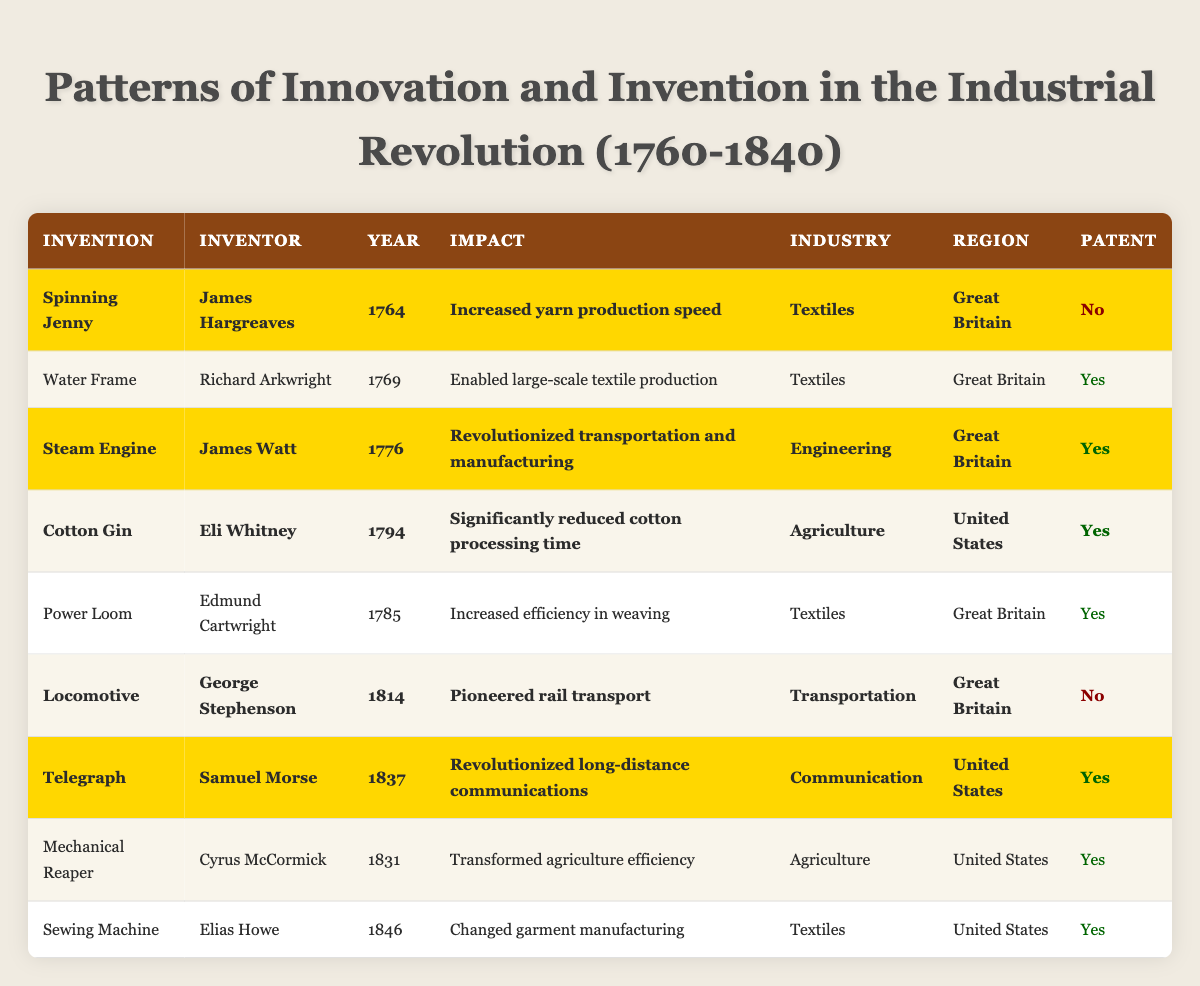What invention was created by James Hargreaves? The table lists James Hargreaves as the inventor of the Spinning Jenny.
Answer: Spinning Jenny Which invention significantly reduced cotton processing time? According to the table, the Cotton Gin, invented by Eli Whitney, is noted for significantly reducing cotton processing time.
Answer: Cotton Gin How many inventions highlighted in the table are from the United States? By counting the highlighted inventions from the United States, we identify three: Cotton Gin, Telegraph, and Locomotive.
Answer: 3 What year was the Steam Engine invented? The table indicates that the Steam Engine was invented in 1776.
Answer: 1776 Did Richard Arkwright patent the Water Frame? The table states that Richard Arkwright did patent the Water Frame, as indicated by "Yes" under the patent column for that invention.
Answer: Yes Which inventor is associated with the invention of the Sewing Machine? The table shows that Elias Howe is the inventor of the Sewing Machine.
Answer: Elias Howe What is the impact of the Telegraph as per the table? According to the table, the Telegraph revolutionized long-distance communications.
Answer: Revolutionized long-distance communications How many inventions were patented that are noted in the textiles industry? By checking the table, we see that three inventions in the textiles industry were patented: Water Frame, Power Loom, and Sewing Machine.
Answer: 3 Did the invention of the Locomotive receive a patent? The table shows that the Locomotive did not receive a patent, as indicated by "No" in the patent column.
Answer: No Which invention was the last to be patented according to the table? Looking at the years listed, the Sewing Machine was patented in 1846, making it the last invention to be patented according to the table.
Answer: Sewing Machine 